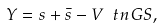Convert formula to latex. <formula><loc_0><loc_0><loc_500><loc_500>Y = s + \bar { s } - V ^ { \ } t n { G S } ,</formula> 